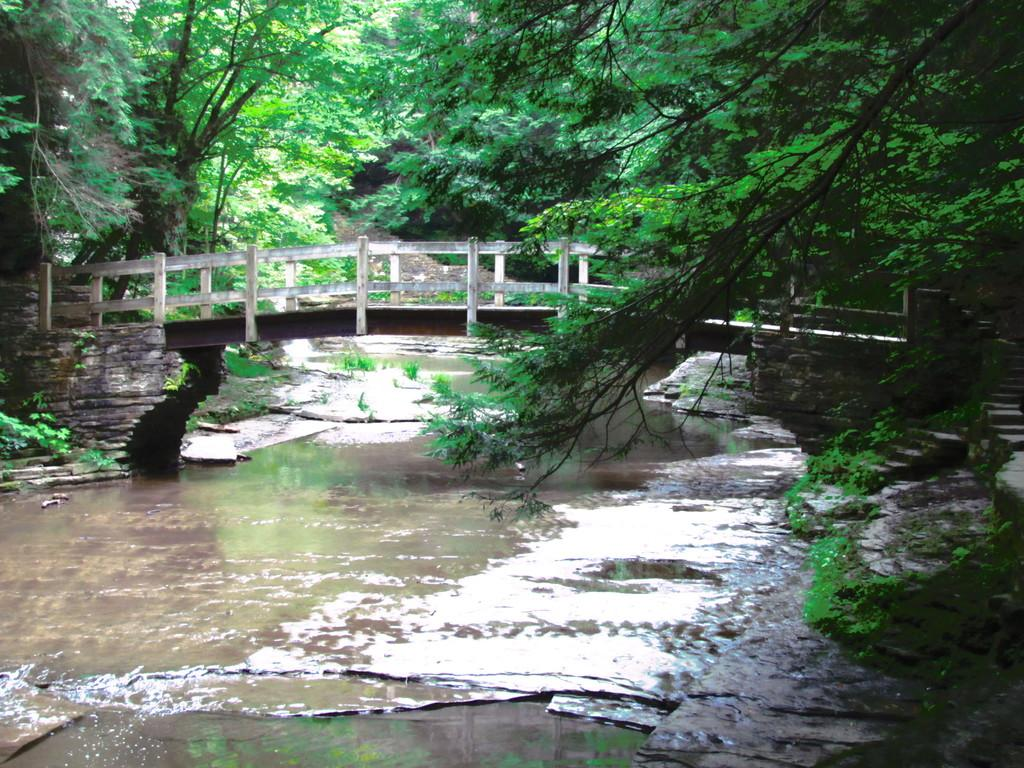What type of natural feature is present in the image? There is a river in the image. What structure can be seen crossing the river? There is a bridge in the image. What type of vegetation is visible in the image? There are trees visible in the image. What type of wire can be seen connecting the trees in the image? There is no wire connecting the trees in the image; only the river, bridge, and trees are present. What word is written on the bridge in the image? There is no word written on the bridge in the image; it is a structure for crossing the river. 